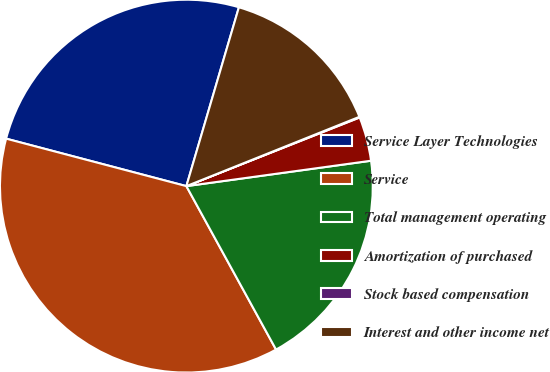Convert chart. <chart><loc_0><loc_0><loc_500><loc_500><pie_chart><fcel>Service Layer Technologies<fcel>Service<fcel>Total management operating<fcel>Amortization of purchased<fcel>Stock based compensation<fcel>Interest and other income net<nl><fcel>25.45%<fcel>37.09%<fcel>19.19%<fcel>3.83%<fcel>0.06%<fcel>14.39%<nl></chart> 